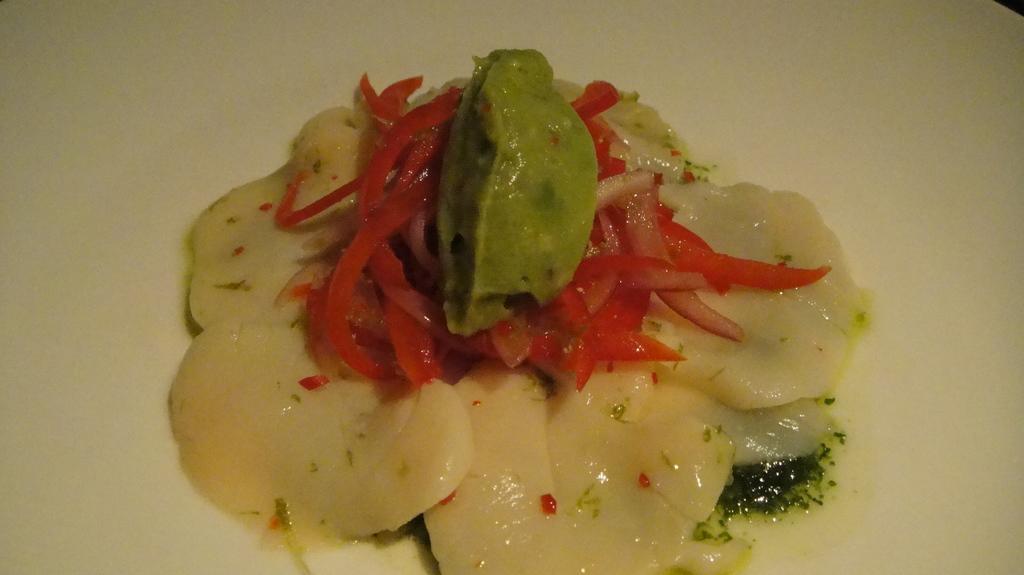Could you give a brief overview of what you see in this image? The picture consists of a food item served in a plate. 